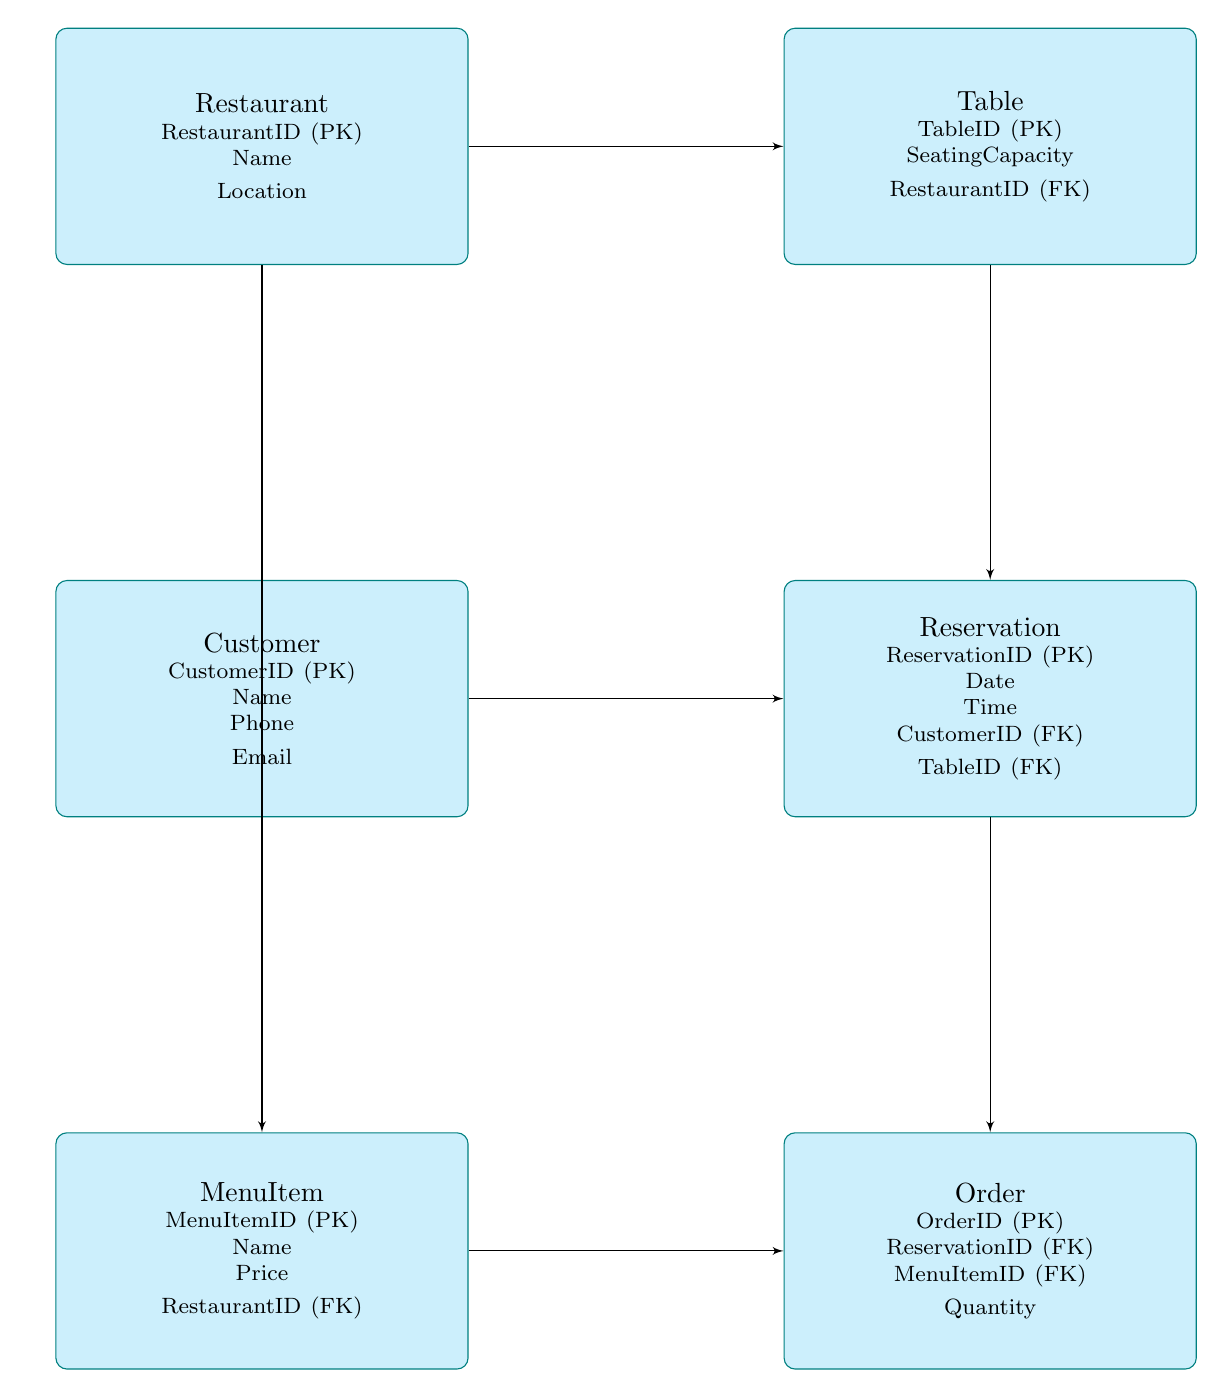What is the primary key of the Customer entity? The primary key of the Customer entity is specified as CustomerID. This can be found by inspecting the attributes listed for the Customer node in the diagram.
Answer: CustomerID How many entities are there in the diagram? To find the number of entities, count the nodes labeled with entity-type information. In this diagram, there are six entities: Restaurant, Table, Customer, Reservation, MenuItem, and Order.
Answer: Six What relationship connects the Reservation entity to the Customer entity? The relationship between the Reservation and Customer entities is through the CustomerID foreign key in the Reservation entity, indicating that each reservation is linked to a specific customer. This means that the reservation system relies on the customer information.
Answer: CustomerID Which entity has the attribute named 'SeatingCapacity'? The attribute 'SeatingCapacity' is found under the Table entity, as this attribute describes the capacity of the tables in the restaurant. This can be verified by reviewing the attribute list associated with the Table node.
Answer: Table How many total foreign keys are present in the Order entity? The Order entity contains two foreign keys: ReservationID and MenuItemID. By examining the attributes under the Order entity, we can identify these foreign keys that link to other entities in the diagram.
Answer: Two What is the relationship between the Reservation entity and the Table entity? The relationship connecting Reservation to Table is via the TableID foreign key in the Reservation entity, indicating that a reservation is made for a specific table. This indicates that each reservation is assigned to a particular table, relating both entities closely.
Answer: TableID Which entity links to MenuItem through a foreign key? The Order entity links to MenuItem through the MenuItemID foreign key. This connection indicates that each order is associated with specific menu items, establishing the relationship between orders and the menu items available in a restaurant.
Answer: Order Name the entity that captures information about the restaurant's location. The Restaurant entity captures information about the restaurant's location, as it includes Location among its attributes. By reviewing the details listed under the Restaurant node, this can be confirmed.
Answer: Restaurant 